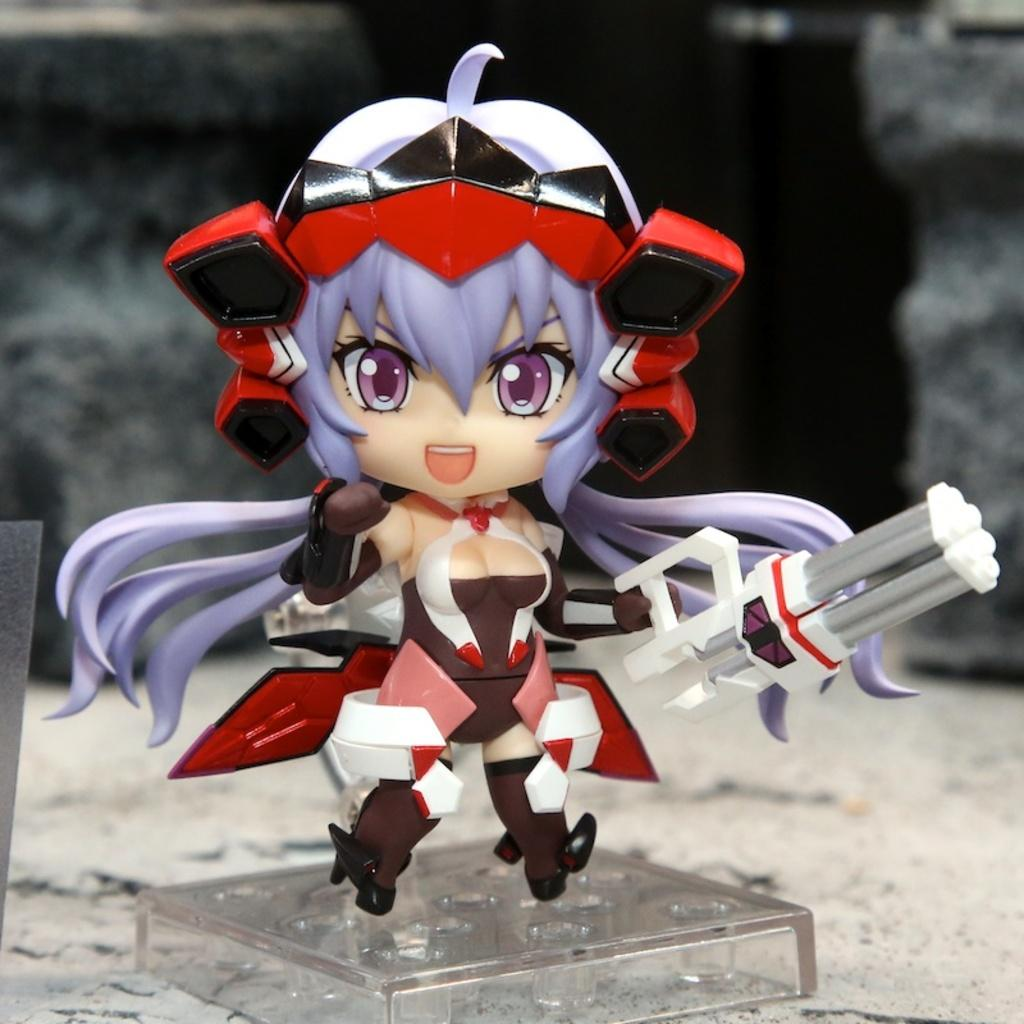What object is placed on a surface in the image? There is a glass cube on a surface in the image. What other item can be seen in the image? There is a girl doll in the image. What is unique about the girl doll's appearance? The girl doll has violet-colored hair. Does the girl doll have any specific attire? The girl doll has some costume. What is the purpose of the beam in the image? There is no beam present in the image. 